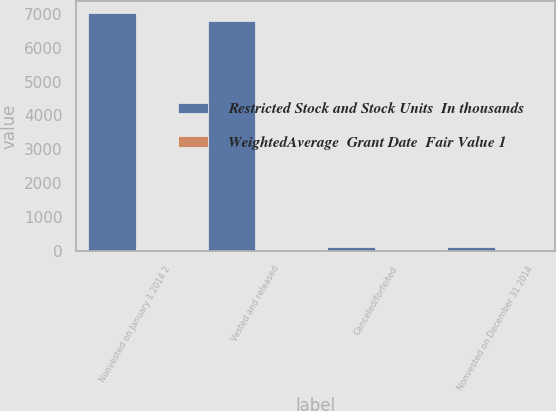Convert chart to OTSL. <chart><loc_0><loc_0><loc_500><loc_500><stacked_bar_chart><ecel><fcel>Nonvested on January 1 2014 2<fcel>Vested and released<fcel>Canceled/forfeited<fcel>Nonvested on December 31 2014<nl><fcel>Restricted Stock and Stock Units  In thousands<fcel>7014<fcel>6774<fcel>110<fcel>130<nl><fcel>WeightedAverage  Grant Date  Fair Value 1<fcel>25.17<fcel>25.17<fcel>25.17<fcel>25.17<nl></chart> 